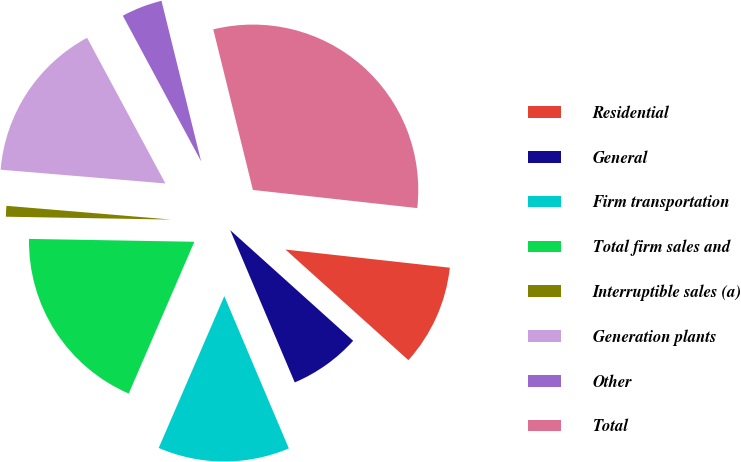<chart> <loc_0><loc_0><loc_500><loc_500><pie_chart><fcel>Residential<fcel>General<fcel>Firm transportation<fcel>Total firm sales and<fcel>Interruptible sales (a)<fcel>Generation plants<fcel>Other<fcel>Total<nl><fcel>9.91%<fcel>6.96%<fcel>12.87%<fcel>18.78%<fcel>1.05%<fcel>15.82%<fcel>4.0%<fcel>30.6%<nl></chart> 